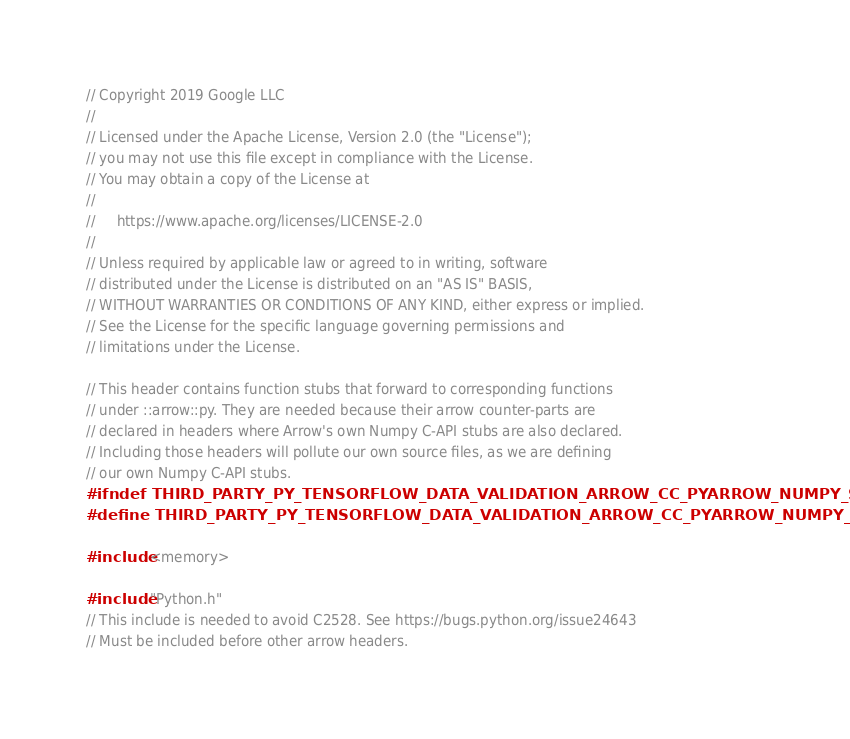Convert code to text. <code><loc_0><loc_0><loc_500><loc_500><_C_>// Copyright 2019 Google LLC
//
// Licensed under the Apache License, Version 2.0 (the "License");
// you may not use this file except in compliance with the License.
// You may obtain a copy of the License at
//
//     https://www.apache.org/licenses/LICENSE-2.0
//
// Unless required by applicable law or agreed to in writing, software
// distributed under the License is distributed on an "AS IS" BASIS,
// WITHOUT WARRANTIES OR CONDITIONS OF ANY KIND, either express or implied.
// See the License for the specific language governing permissions and
// limitations under the License.

// This header contains function stubs that forward to corresponding functions
// under ::arrow::py. They are needed because their arrow counter-parts are
// declared in headers where Arrow's own Numpy C-API stubs are also declared.
// Including those headers will pollute our own source files, as we are defining
// our own Numpy C-API stubs.
#ifndef THIRD_PARTY_PY_TENSORFLOW_DATA_VALIDATION_ARROW_CC_PYARROW_NUMPY_STUB_H_
#define THIRD_PARTY_PY_TENSORFLOW_DATA_VALIDATION_ARROW_CC_PYARROW_NUMPY_STUB_H_

#include <memory>

#include "Python.h"
// This include is needed to avoid C2528. See https://bugs.python.org/issue24643
// Must be included before other arrow headers.</code> 